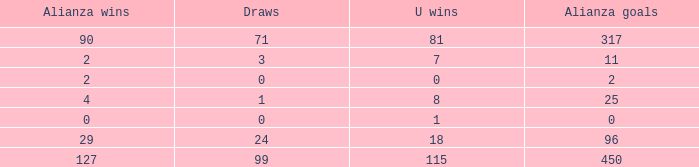What is the sum of Alianza Wins, when Alianza Goals is "317, and when U Goals is greater than 296? None. 